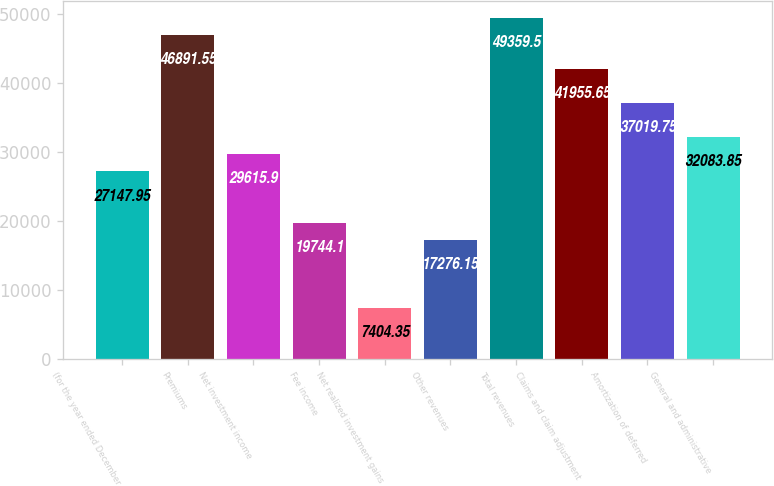Convert chart. <chart><loc_0><loc_0><loc_500><loc_500><bar_chart><fcel>(for the year ended December<fcel>Premiums<fcel>Net investment income<fcel>Fee income<fcel>Net realized investment gains<fcel>Other revenues<fcel>Total revenues<fcel>Claims and claim adjustment<fcel>Amortization of deferred<fcel>General and administrative<nl><fcel>27148<fcel>46891.6<fcel>29615.9<fcel>19744.1<fcel>7404.35<fcel>17276.2<fcel>49359.5<fcel>41955.7<fcel>37019.8<fcel>32083.8<nl></chart> 